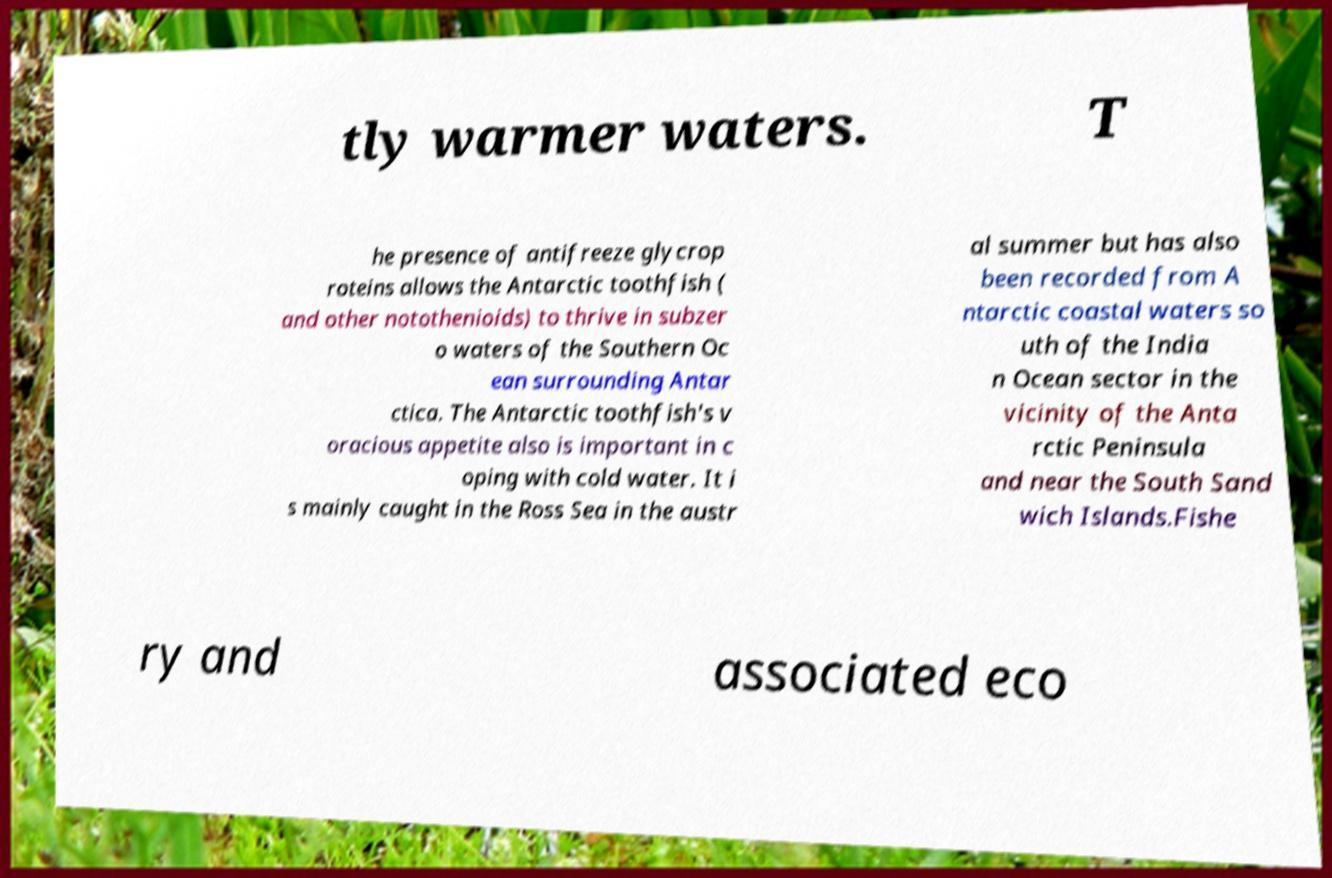Can you read and provide the text displayed in the image?This photo seems to have some interesting text. Can you extract and type it out for me? tly warmer waters. T he presence of antifreeze glycrop roteins allows the Antarctic toothfish ( and other notothenioids) to thrive in subzer o waters of the Southern Oc ean surrounding Antar ctica. The Antarctic toothfish's v oracious appetite also is important in c oping with cold water. It i s mainly caught in the Ross Sea in the austr al summer but has also been recorded from A ntarctic coastal waters so uth of the India n Ocean sector in the vicinity of the Anta rctic Peninsula and near the South Sand wich Islands.Fishe ry and associated eco 